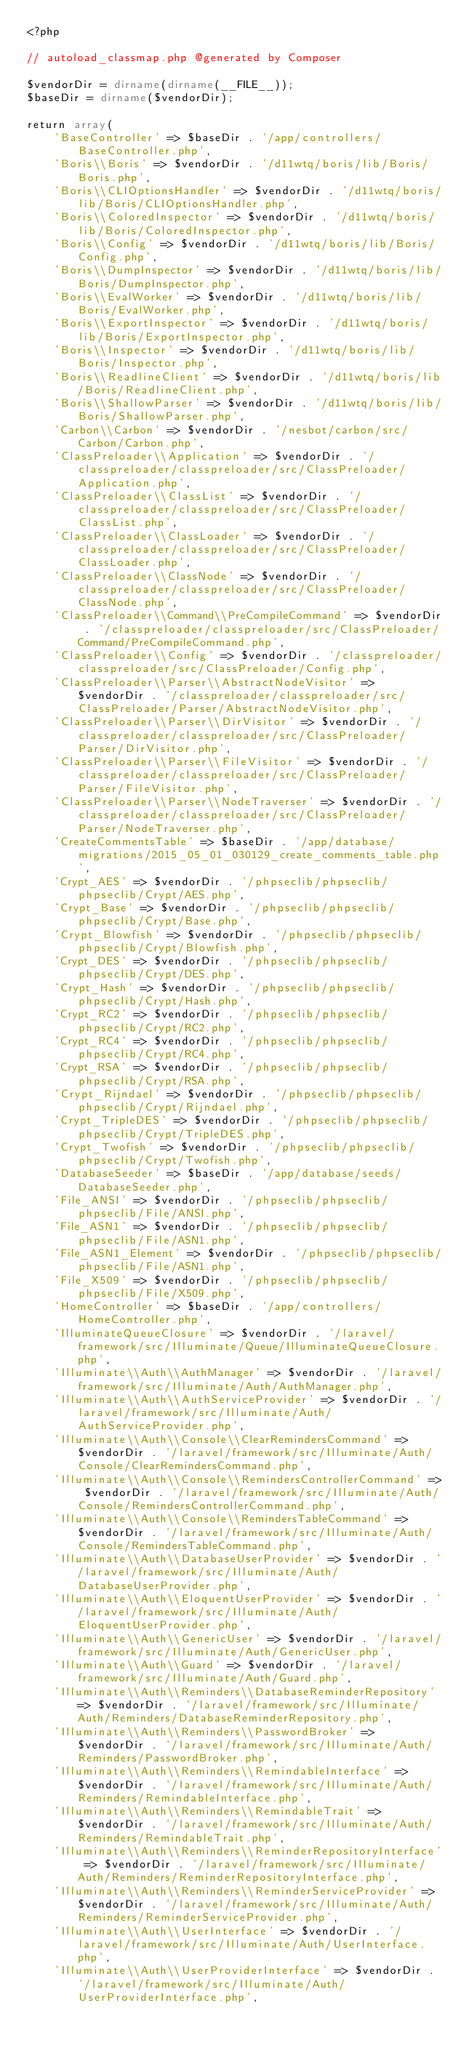<code> <loc_0><loc_0><loc_500><loc_500><_PHP_><?php

// autoload_classmap.php @generated by Composer

$vendorDir = dirname(dirname(__FILE__));
$baseDir = dirname($vendorDir);

return array(
    'BaseController' => $baseDir . '/app/controllers/BaseController.php',
    'Boris\\Boris' => $vendorDir . '/d11wtq/boris/lib/Boris/Boris.php',
    'Boris\\CLIOptionsHandler' => $vendorDir . '/d11wtq/boris/lib/Boris/CLIOptionsHandler.php',
    'Boris\\ColoredInspector' => $vendorDir . '/d11wtq/boris/lib/Boris/ColoredInspector.php',
    'Boris\\Config' => $vendorDir . '/d11wtq/boris/lib/Boris/Config.php',
    'Boris\\DumpInspector' => $vendorDir . '/d11wtq/boris/lib/Boris/DumpInspector.php',
    'Boris\\EvalWorker' => $vendorDir . '/d11wtq/boris/lib/Boris/EvalWorker.php',
    'Boris\\ExportInspector' => $vendorDir . '/d11wtq/boris/lib/Boris/ExportInspector.php',
    'Boris\\Inspector' => $vendorDir . '/d11wtq/boris/lib/Boris/Inspector.php',
    'Boris\\ReadlineClient' => $vendorDir . '/d11wtq/boris/lib/Boris/ReadlineClient.php',
    'Boris\\ShallowParser' => $vendorDir . '/d11wtq/boris/lib/Boris/ShallowParser.php',
    'Carbon\\Carbon' => $vendorDir . '/nesbot/carbon/src/Carbon/Carbon.php',
    'ClassPreloader\\Application' => $vendorDir . '/classpreloader/classpreloader/src/ClassPreloader/Application.php',
    'ClassPreloader\\ClassList' => $vendorDir . '/classpreloader/classpreloader/src/ClassPreloader/ClassList.php',
    'ClassPreloader\\ClassLoader' => $vendorDir . '/classpreloader/classpreloader/src/ClassPreloader/ClassLoader.php',
    'ClassPreloader\\ClassNode' => $vendorDir . '/classpreloader/classpreloader/src/ClassPreloader/ClassNode.php',
    'ClassPreloader\\Command\\PreCompileCommand' => $vendorDir . '/classpreloader/classpreloader/src/ClassPreloader/Command/PreCompileCommand.php',
    'ClassPreloader\\Config' => $vendorDir . '/classpreloader/classpreloader/src/ClassPreloader/Config.php',
    'ClassPreloader\\Parser\\AbstractNodeVisitor' => $vendorDir . '/classpreloader/classpreloader/src/ClassPreloader/Parser/AbstractNodeVisitor.php',
    'ClassPreloader\\Parser\\DirVisitor' => $vendorDir . '/classpreloader/classpreloader/src/ClassPreloader/Parser/DirVisitor.php',
    'ClassPreloader\\Parser\\FileVisitor' => $vendorDir . '/classpreloader/classpreloader/src/ClassPreloader/Parser/FileVisitor.php',
    'ClassPreloader\\Parser\\NodeTraverser' => $vendorDir . '/classpreloader/classpreloader/src/ClassPreloader/Parser/NodeTraverser.php',
    'CreateCommentsTable' => $baseDir . '/app/database/migrations/2015_05_01_030129_create_comments_table.php',
    'Crypt_AES' => $vendorDir . '/phpseclib/phpseclib/phpseclib/Crypt/AES.php',
    'Crypt_Base' => $vendorDir . '/phpseclib/phpseclib/phpseclib/Crypt/Base.php',
    'Crypt_Blowfish' => $vendorDir . '/phpseclib/phpseclib/phpseclib/Crypt/Blowfish.php',
    'Crypt_DES' => $vendorDir . '/phpseclib/phpseclib/phpseclib/Crypt/DES.php',
    'Crypt_Hash' => $vendorDir . '/phpseclib/phpseclib/phpseclib/Crypt/Hash.php',
    'Crypt_RC2' => $vendorDir . '/phpseclib/phpseclib/phpseclib/Crypt/RC2.php',
    'Crypt_RC4' => $vendorDir . '/phpseclib/phpseclib/phpseclib/Crypt/RC4.php',
    'Crypt_RSA' => $vendorDir . '/phpseclib/phpseclib/phpseclib/Crypt/RSA.php',
    'Crypt_Rijndael' => $vendorDir . '/phpseclib/phpseclib/phpseclib/Crypt/Rijndael.php',
    'Crypt_TripleDES' => $vendorDir . '/phpseclib/phpseclib/phpseclib/Crypt/TripleDES.php',
    'Crypt_Twofish' => $vendorDir . '/phpseclib/phpseclib/phpseclib/Crypt/Twofish.php',
    'DatabaseSeeder' => $baseDir . '/app/database/seeds/DatabaseSeeder.php',
    'File_ANSI' => $vendorDir . '/phpseclib/phpseclib/phpseclib/File/ANSI.php',
    'File_ASN1' => $vendorDir . '/phpseclib/phpseclib/phpseclib/File/ASN1.php',
    'File_ASN1_Element' => $vendorDir . '/phpseclib/phpseclib/phpseclib/File/ASN1.php',
    'File_X509' => $vendorDir . '/phpseclib/phpseclib/phpseclib/File/X509.php',
    'HomeController' => $baseDir . '/app/controllers/HomeController.php',
    'IlluminateQueueClosure' => $vendorDir . '/laravel/framework/src/Illuminate/Queue/IlluminateQueueClosure.php',
    'Illuminate\\Auth\\AuthManager' => $vendorDir . '/laravel/framework/src/Illuminate/Auth/AuthManager.php',
    'Illuminate\\Auth\\AuthServiceProvider' => $vendorDir . '/laravel/framework/src/Illuminate/Auth/AuthServiceProvider.php',
    'Illuminate\\Auth\\Console\\ClearRemindersCommand' => $vendorDir . '/laravel/framework/src/Illuminate/Auth/Console/ClearRemindersCommand.php',
    'Illuminate\\Auth\\Console\\RemindersControllerCommand' => $vendorDir . '/laravel/framework/src/Illuminate/Auth/Console/RemindersControllerCommand.php',
    'Illuminate\\Auth\\Console\\RemindersTableCommand' => $vendorDir . '/laravel/framework/src/Illuminate/Auth/Console/RemindersTableCommand.php',
    'Illuminate\\Auth\\DatabaseUserProvider' => $vendorDir . '/laravel/framework/src/Illuminate/Auth/DatabaseUserProvider.php',
    'Illuminate\\Auth\\EloquentUserProvider' => $vendorDir . '/laravel/framework/src/Illuminate/Auth/EloquentUserProvider.php',
    'Illuminate\\Auth\\GenericUser' => $vendorDir . '/laravel/framework/src/Illuminate/Auth/GenericUser.php',
    'Illuminate\\Auth\\Guard' => $vendorDir . '/laravel/framework/src/Illuminate/Auth/Guard.php',
    'Illuminate\\Auth\\Reminders\\DatabaseReminderRepository' => $vendorDir . '/laravel/framework/src/Illuminate/Auth/Reminders/DatabaseReminderRepository.php',
    'Illuminate\\Auth\\Reminders\\PasswordBroker' => $vendorDir . '/laravel/framework/src/Illuminate/Auth/Reminders/PasswordBroker.php',
    'Illuminate\\Auth\\Reminders\\RemindableInterface' => $vendorDir . '/laravel/framework/src/Illuminate/Auth/Reminders/RemindableInterface.php',
    'Illuminate\\Auth\\Reminders\\RemindableTrait' => $vendorDir . '/laravel/framework/src/Illuminate/Auth/Reminders/RemindableTrait.php',
    'Illuminate\\Auth\\Reminders\\ReminderRepositoryInterface' => $vendorDir . '/laravel/framework/src/Illuminate/Auth/Reminders/ReminderRepositoryInterface.php',
    'Illuminate\\Auth\\Reminders\\ReminderServiceProvider' => $vendorDir . '/laravel/framework/src/Illuminate/Auth/Reminders/ReminderServiceProvider.php',
    'Illuminate\\Auth\\UserInterface' => $vendorDir . '/laravel/framework/src/Illuminate/Auth/UserInterface.php',
    'Illuminate\\Auth\\UserProviderInterface' => $vendorDir . '/laravel/framework/src/Illuminate/Auth/UserProviderInterface.php',</code> 